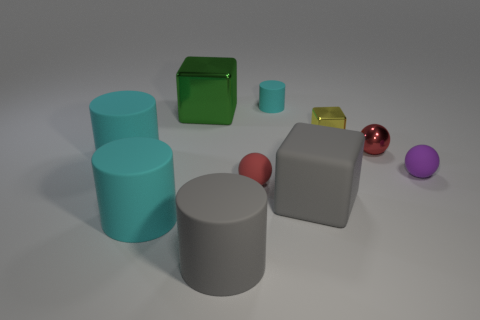Subtract all cyan cylinders. How many cylinders are left? 1 Subtract all big green shiny blocks. How many blocks are left? 2 Subtract all yellow cubes. How many green balls are left? 0 Subtract all cylinders. How many objects are left? 6 Subtract 2 cylinders. How many cylinders are left? 2 Subtract all red balls. Subtract all cyan cylinders. How many balls are left? 1 Subtract all tiny red rubber balls. Subtract all gray blocks. How many objects are left? 8 Add 9 purple rubber things. How many purple rubber things are left? 10 Add 8 big blue matte balls. How many big blue matte balls exist? 8 Subtract 1 purple spheres. How many objects are left? 9 